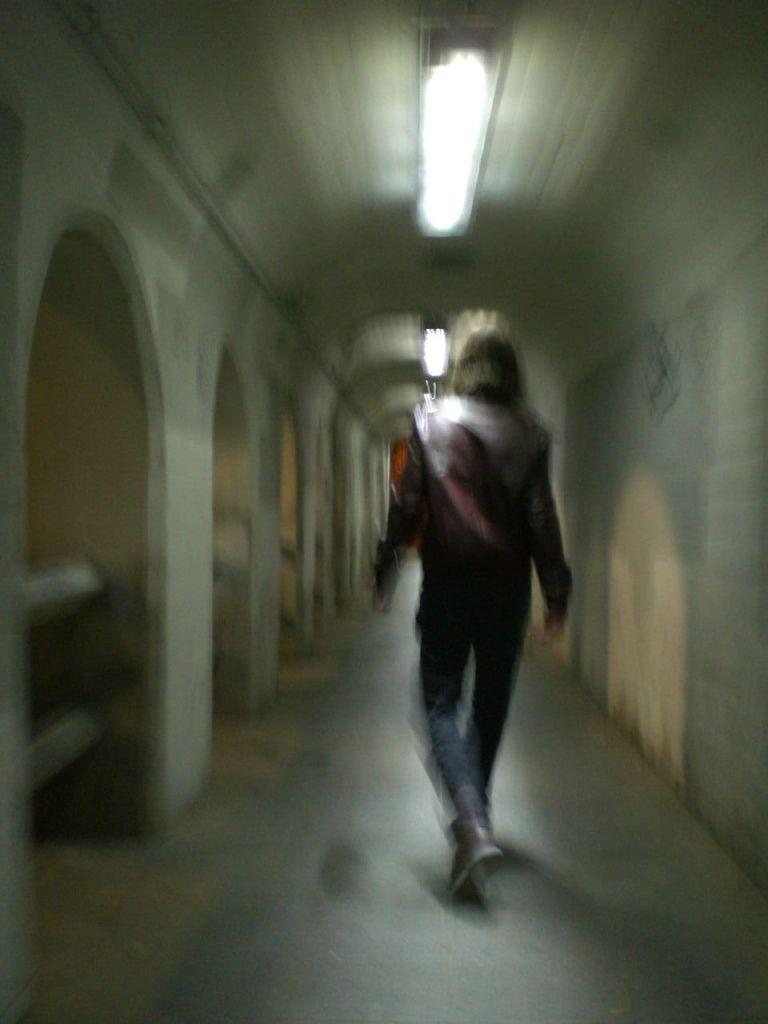What is the main action being performed by the person in the image? The person is walking in the image. On what surface is the person walking? The person is walking on the floor. What can be seen on the left side of the image? There is an arch design construction on the left side of the image. What is present at the top of the image? There is a lighting arrangement at the top of the image. How many children are holding cherries in the image? There are no children or cherries present in the image. What type of salt is sprinkled on the floor in the image? There is no salt present in the image; the person is walking on the floor without any salt. 